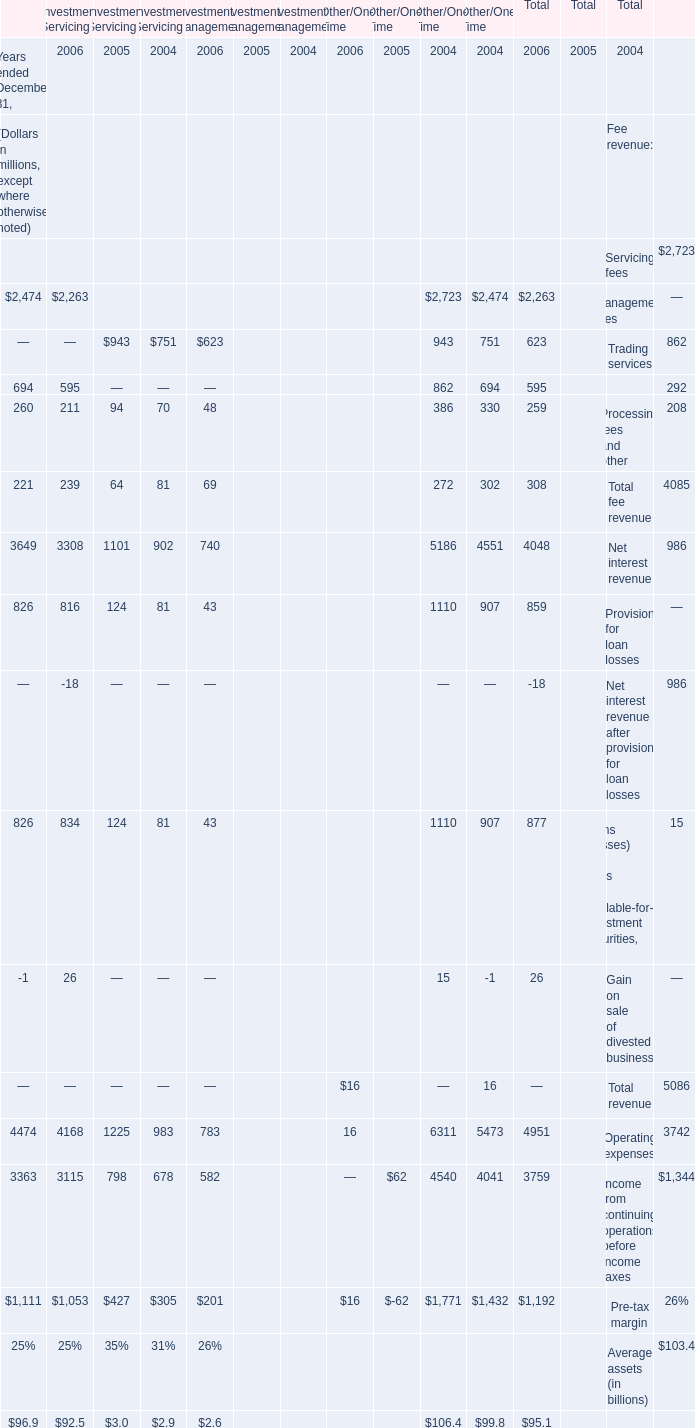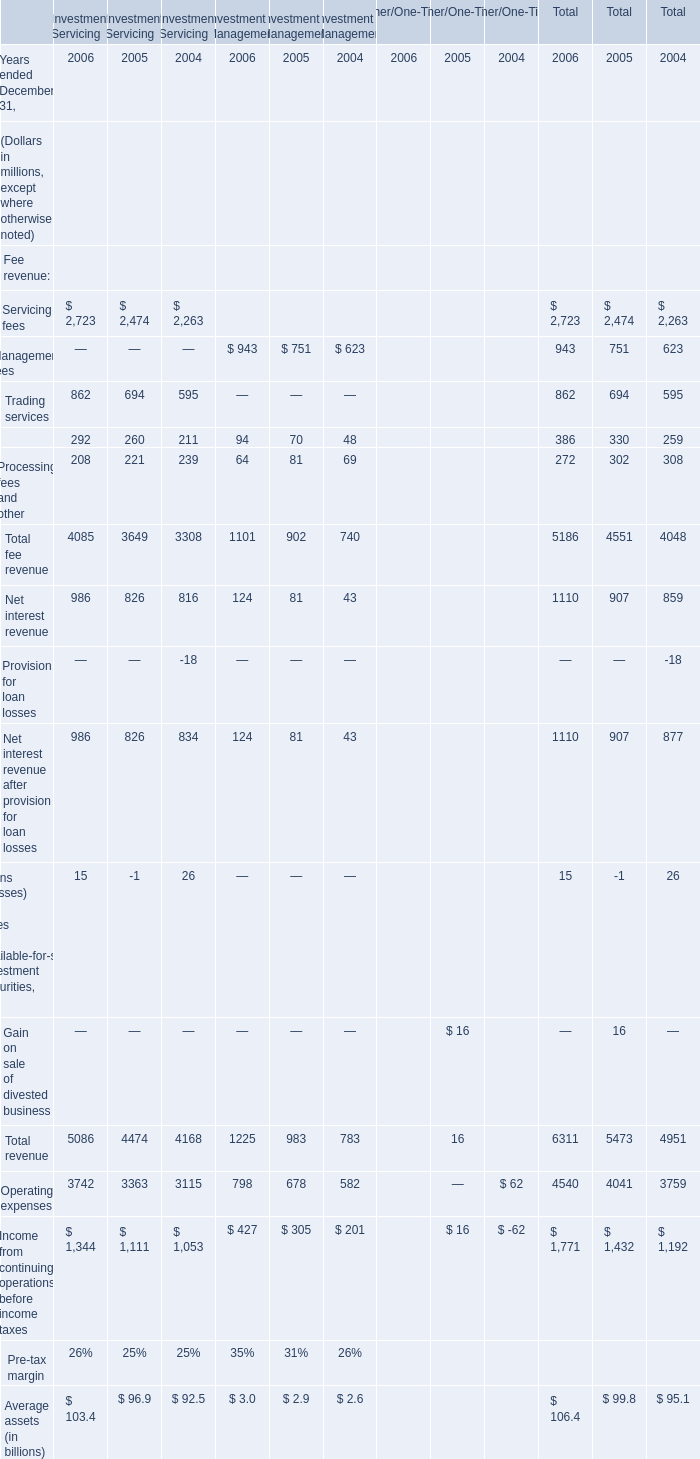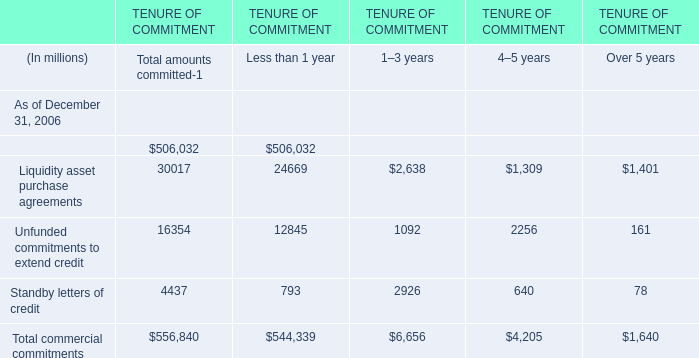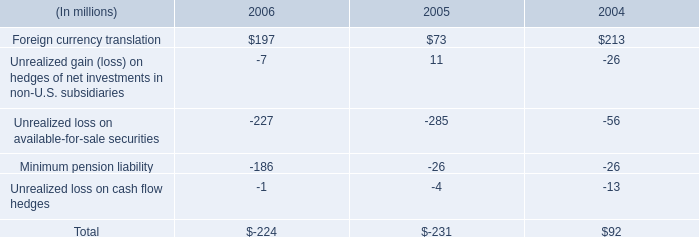what is the percentage change in total assets in unconsolidated conduits from 2005 to 2006? 
Computations: ((25.25 - 17.90) / 17.90)
Answer: 0.41061. 